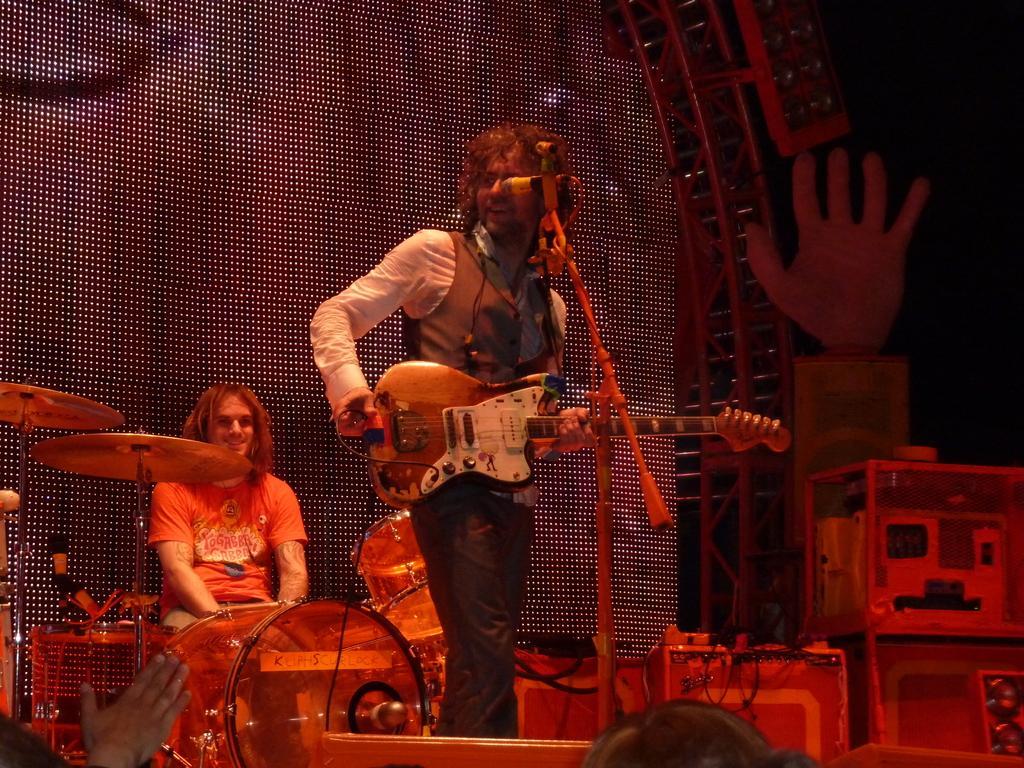How would you summarize this image in a sentence or two? This is a picture taken in a stage, there are two people on the stage a man holding a guitar and the other man in orange t shirt playing the music instruments. Background of this people is a screen and a music systems. 